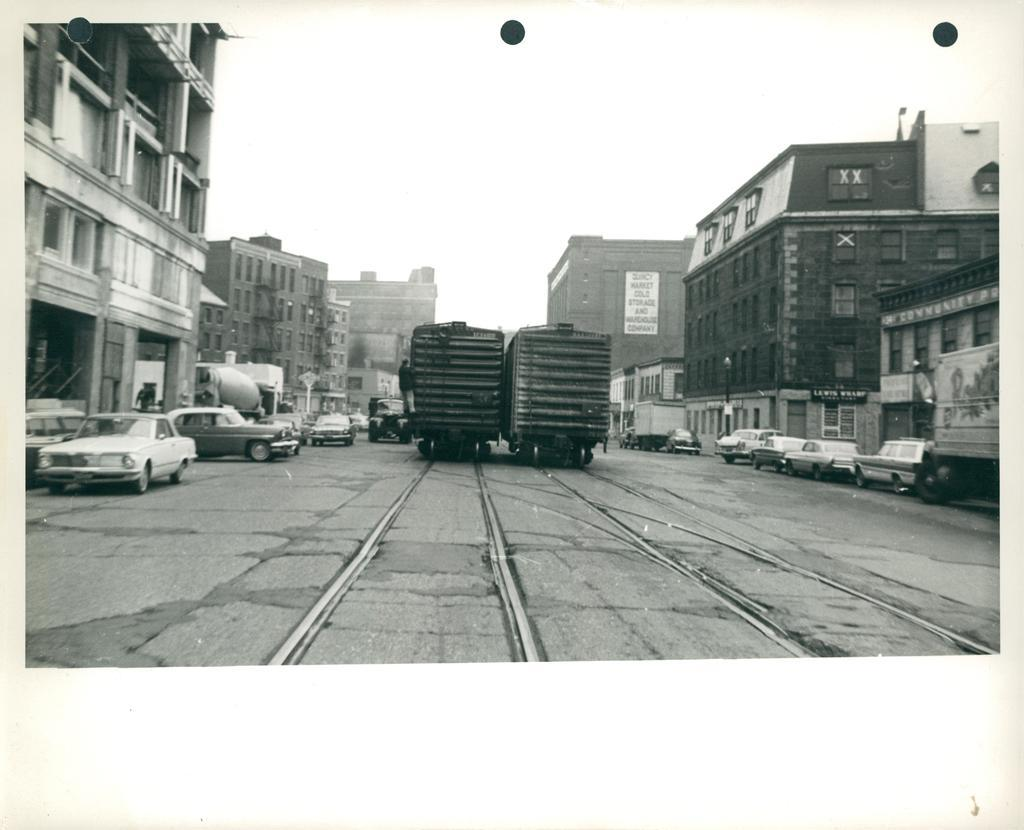What is the color scheme of the image? The image is black and white. What can be seen on the road in the image? There are vehicles on the road. What structures are located beside the vehicles? There are buildings beside the vehicles. What feature do the buildings have? The buildings have windows. Is there any signage or advertisement visible on the buildings? Yes, there is a hoarding on one of the buildings. What type of shoes is the person wearing while walking on the road in the image? There is no person walking on the road in the image, so it is not possible to determine what type of shoes they might be wearing. 